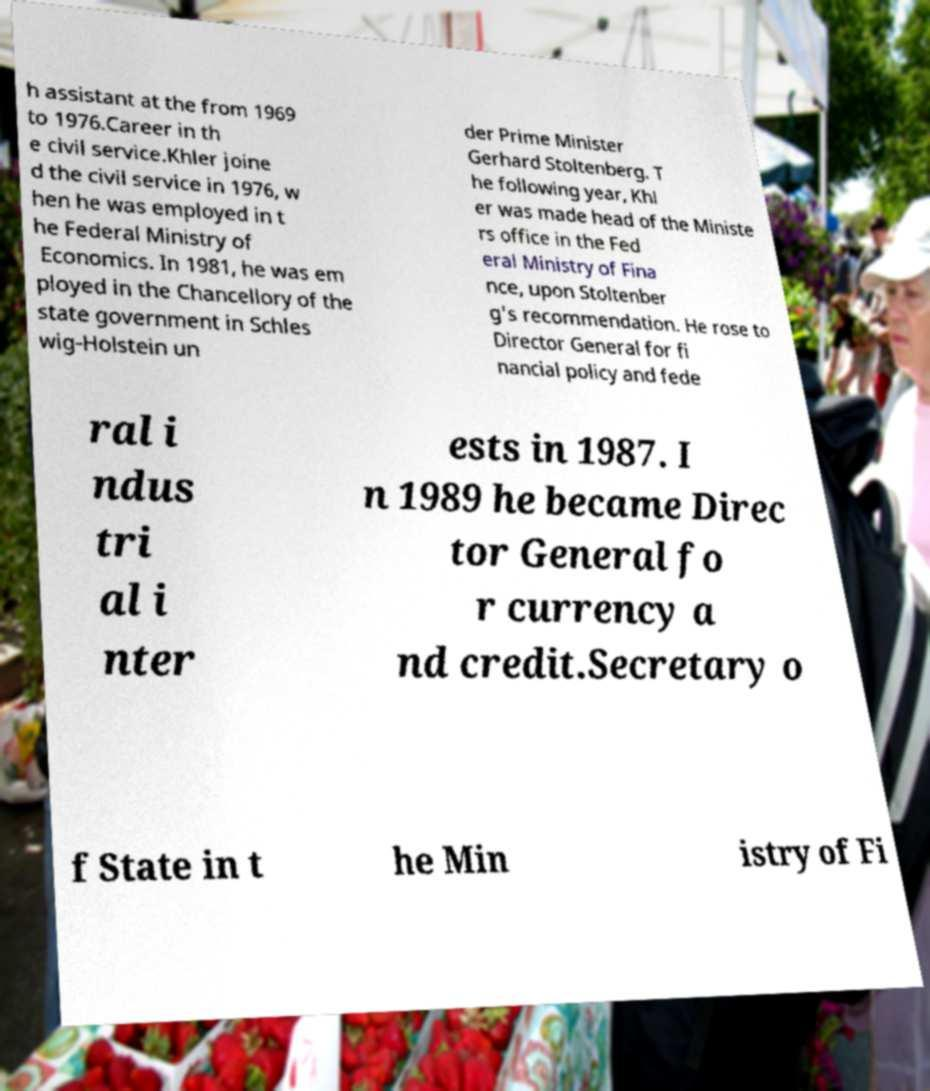Please identify and transcribe the text found in this image. h assistant at the from 1969 to 1976.Career in th e civil service.Khler joine d the civil service in 1976, w hen he was employed in t he Federal Ministry of Economics. In 1981, he was em ployed in the Chancellory of the state government in Schles wig-Holstein un der Prime Minister Gerhard Stoltenberg. T he following year, Khl er was made head of the Ministe rs office in the Fed eral Ministry of Fina nce, upon Stoltenber g's recommendation. He rose to Director General for fi nancial policy and fede ral i ndus tri al i nter ests in 1987. I n 1989 he became Direc tor General fo r currency a nd credit.Secretary o f State in t he Min istry of Fi 